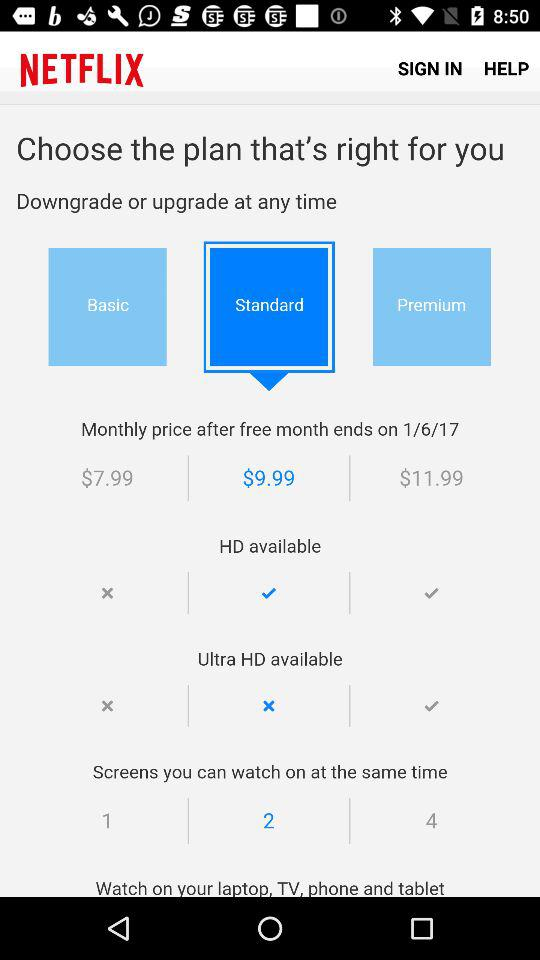How many screens can I watch at the same time on the standard plan? You can watch two screens at the same time on the standard plan. 